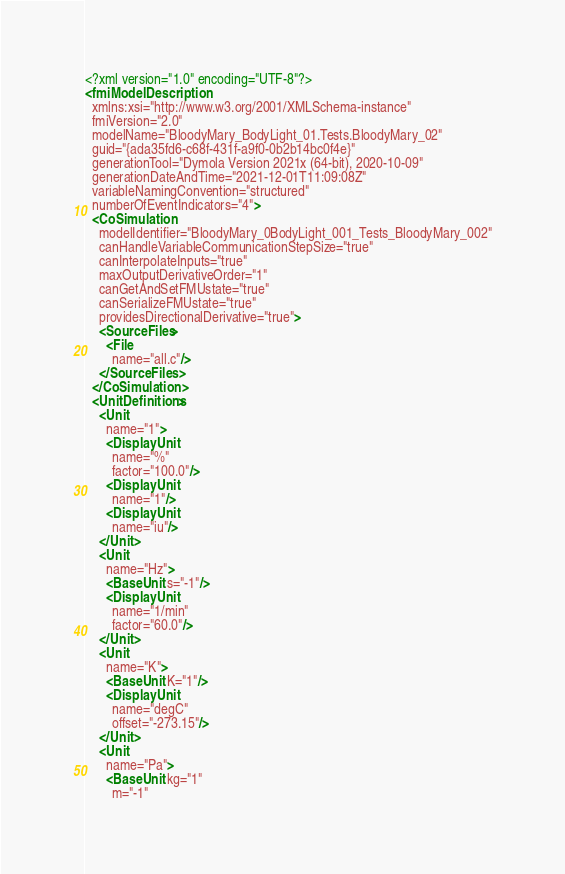Convert code to text. <code><loc_0><loc_0><loc_500><loc_500><_XML_><?xml version="1.0" encoding="UTF-8"?>
<fmiModelDescription
  xmlns:xsi="http://www.w3.org/2001/XMLSchema-instance"
  fmiVersion="2.0"
  modelName="BloodyMary_BodyLight_01.Tests.BloodyMary_02"
  guid="{ada35fd6-c68f-431f-a9f0-0b2b14bc0f4e}"
  generationTool="Dymola Version 2021x (64-bit), 2020-10-09"
  generationDateAndTime="2021-12-01T11:09:08Z"
  variableNamingConvention="structured"
  numberOfEventIndicators="4">
  <CoSimulation
    modelIdentifier="BloodyMary_0BodyLight_001_Tests_BloodyMary_002"
    canHandleVariableCommunicationStepSize="true"
    canInterpolateInputs="true"
    maxOutputDerivativeOrder="1"
    canGetAndSetFMUstate="true"
    canSerializeFMUstate="true"
    providesDirectionalDerivative="true">
    <SourceFiles>
      <File
        name="all.c"/>
    </SourceFiles>
  </CoSimulation>
  <UnitDefinitions>
    <Unit
      name="1">
      <DisplayUnit
        name="%"
        factor="100.0"/>
      <DisplayUnit
        name="1"/>
      <DisplayUnit
        name="iu"/>
    </Unit>
    <Unit
      name="Hz">
      <BaseUnit s="-1"/>
      <DisplayUnit
        name="1/min"
        factor="60.0"/>
    </Unit>
    <Unit
      name="K">
      <BaseUnit K="1"/>
      <DisplayUnit
        name="degC"
        offset="-273.15"/>
    </Unit>
    <Unit
      name="Pa">
      <BaseUnit kg="1"
        m="-1"</code> 